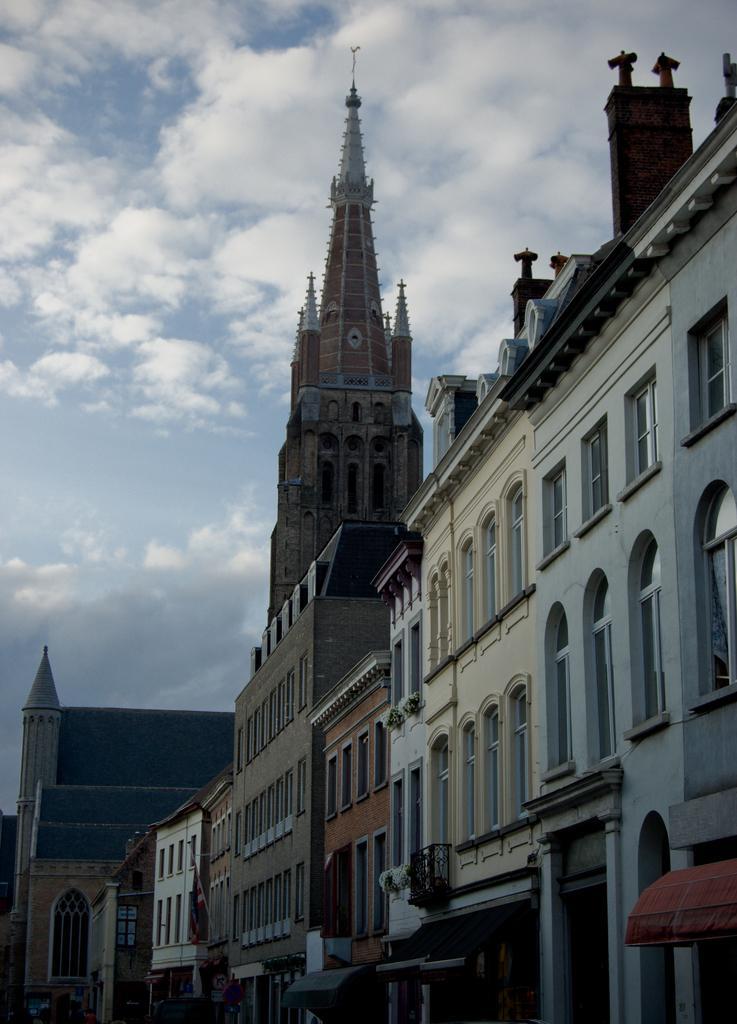In one or two sentences, can you explain what this image depicts? There are many buildings with windows. In the background there is sky with clouds. 